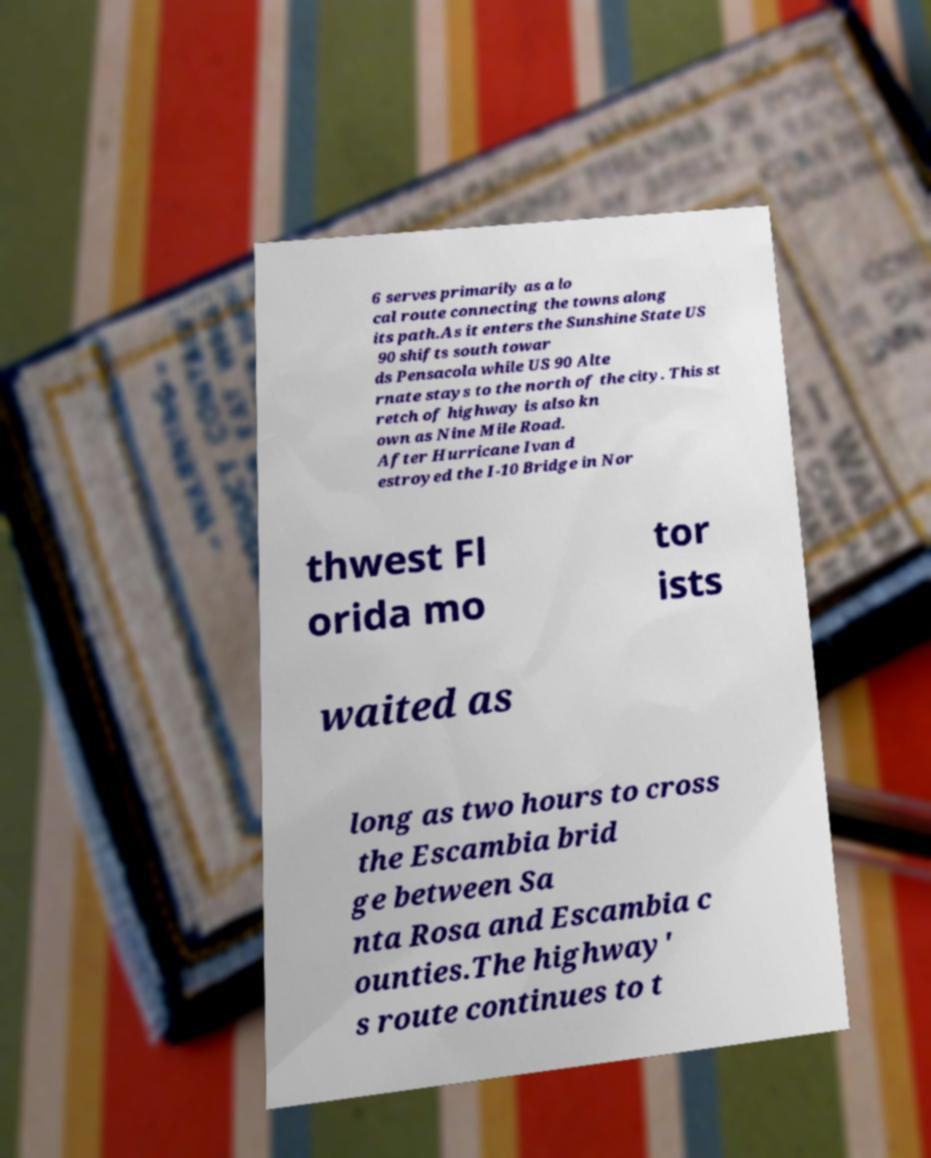Please read and relay the text visible in this image. What does it say? 6 serves primarily as a lo cal route connecting the towns along its path.As it enters the Sunshine State US 90 shifts south towar ds Pensacola while US 90 Alte rnate stays to the north of the city. This st retch of highway is also kn own as Nine Mile Road. After Hurricane Ivan d estroyed the I-10 Bridge in Nor thwest Fl orida mo tor ists waited as long as two hours to cross the Escambia brid ge between Sa nta Rosa and Escambia c ounties.The highway' s route continues to t 